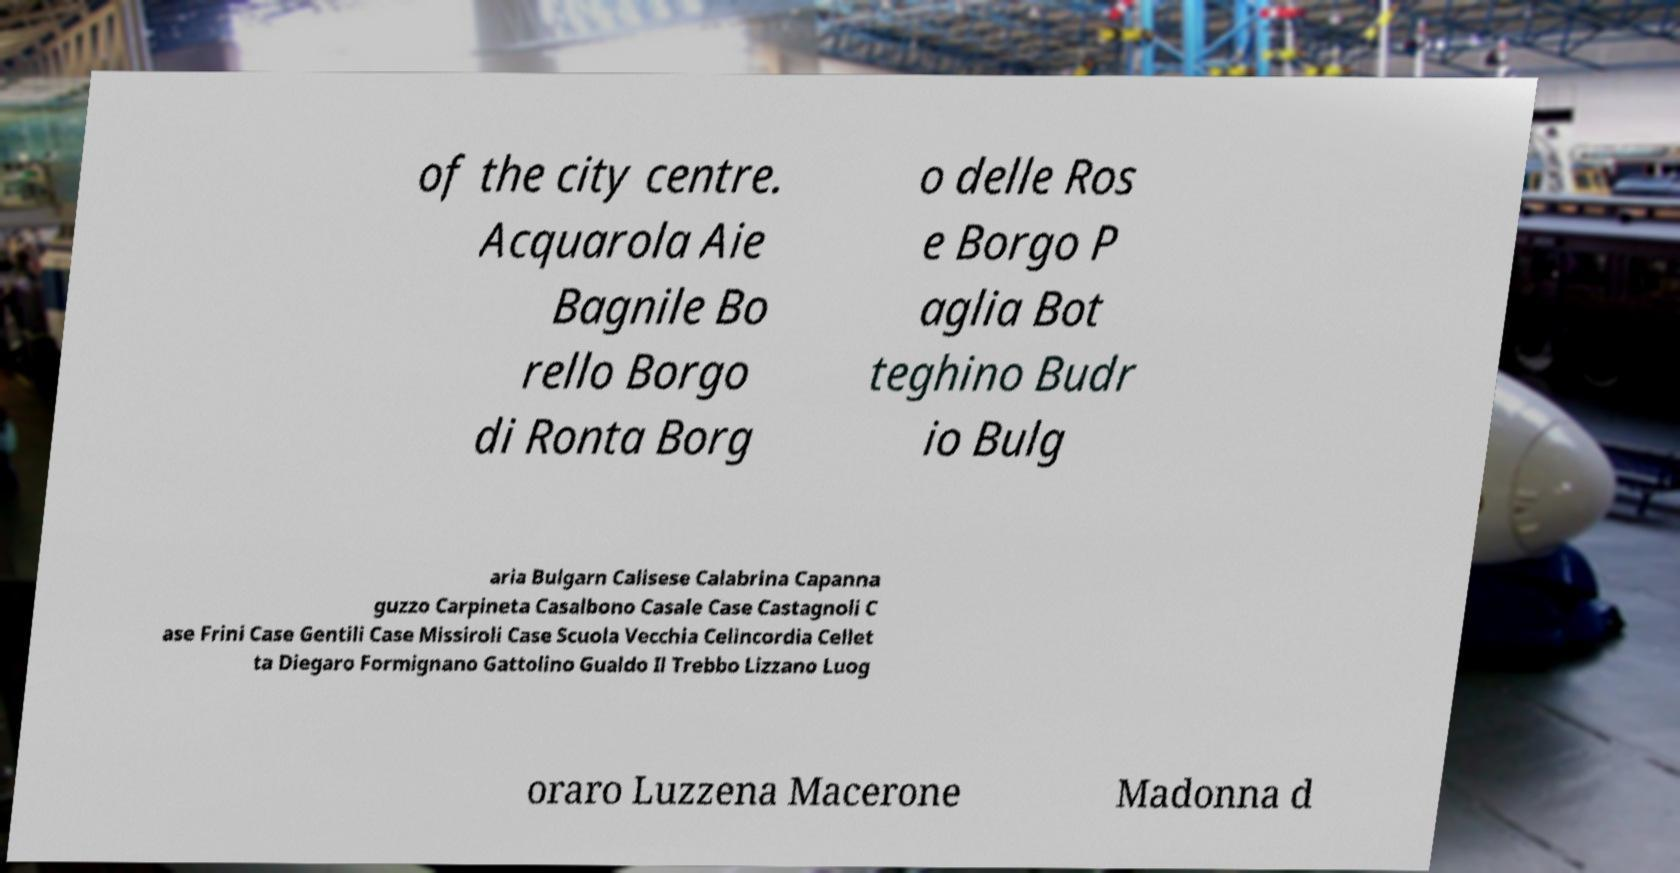Could you assist in decoding the text presented in this image and type it out clearly? of the city centre. Acquarola Aie Bagnile Bo rello Borgo di Ronta Borg o delle Ros e Borgo P aglia Bot teghino Budr io Bulg aria Bulgarn Calisese Calabrina Capanna guzzo Carpineta Casalbono Casale Case Castagnoli C ase Frini Case Gentili Case Missiroli Case Scuola Vecchia Celincordia Cellet ta Diegaro Formignano Gattolino Gualdo Il Trebbo Lizzano Luog oraro Luzzena Macerone Madonna d 